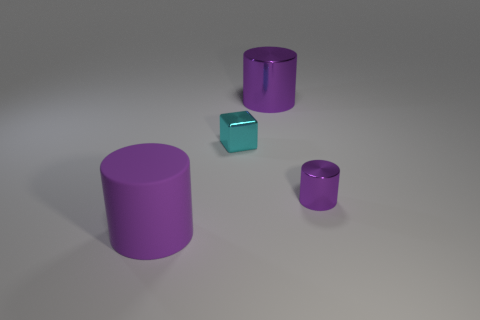What shape is the big thing that is the same material as the tiny cylinder?
Your response must be concise. Cylinder. How many big things are purple shiny things or purple rubber things?
Ensure brevity in your answer.  2. What number of other objects are the same color as the tiny cylinder?
Offer a very short reply. 2. There is a large purple cylinder that is left of the large purple cylinder that is on the right side of the big purple matte cylinder; how many big purple rubber cylinders are behind it?
Your answer should be very brief. 0. There is a purple cylinder on the left side of the block; is its size the same as the cyan metallic block?
Ensure brevity in your answer.  No. Are there fewer small cyan metal things on the left side of the tiny cyan thing than small metallic things to the left of the tiny metal cylinder?
Your answer should be very brief. Yes. Does the large matte thing have the same color as the small cylinder?
Keep it short and to the point. Yes. Are there fewer cyan metal blocks that are behind the cyan metal thing than big brown things?
Offer a terse response. No. There is a big object that is the same color as the large shiny cylinder; what material is it?
Provide a succinct answer. Rubber. How many big things have the same material as the cyan cube?
Your response must be concise. 1. 